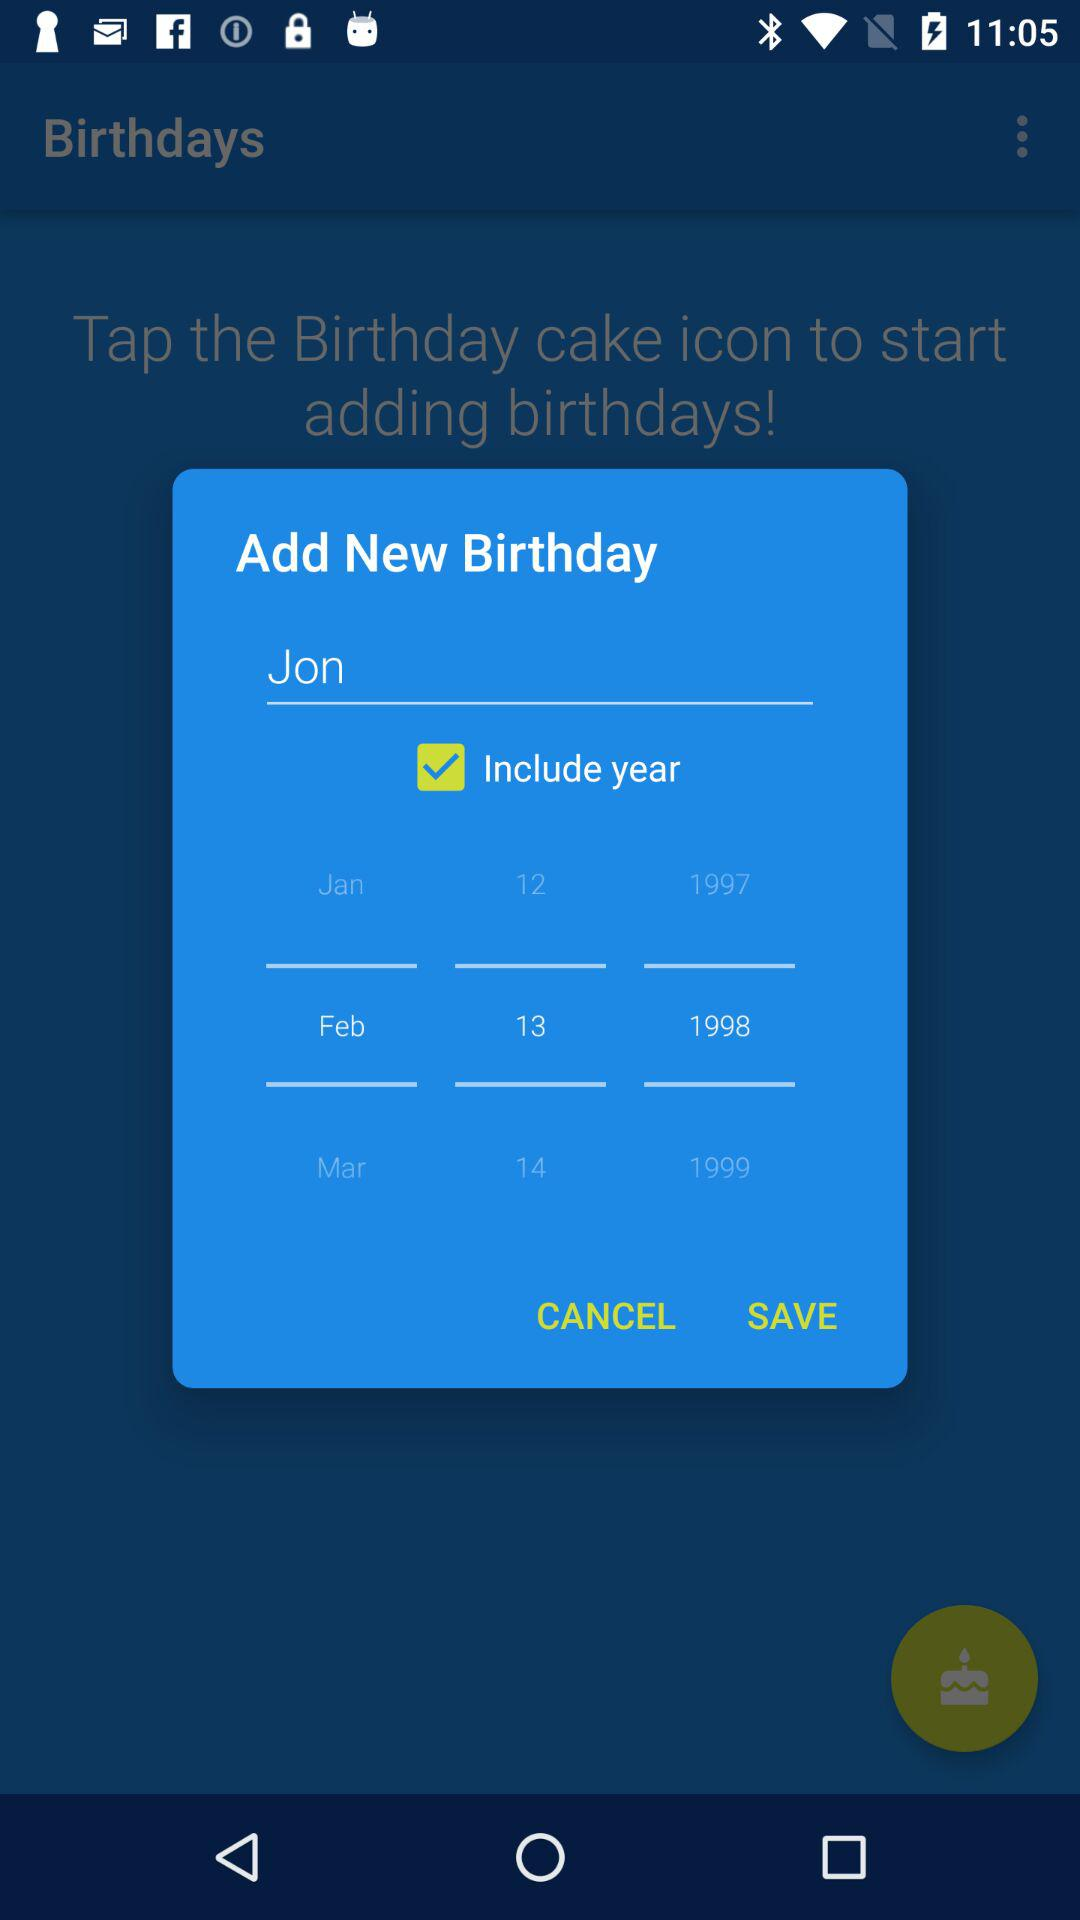What option is checked? The checked option is "Include year". 